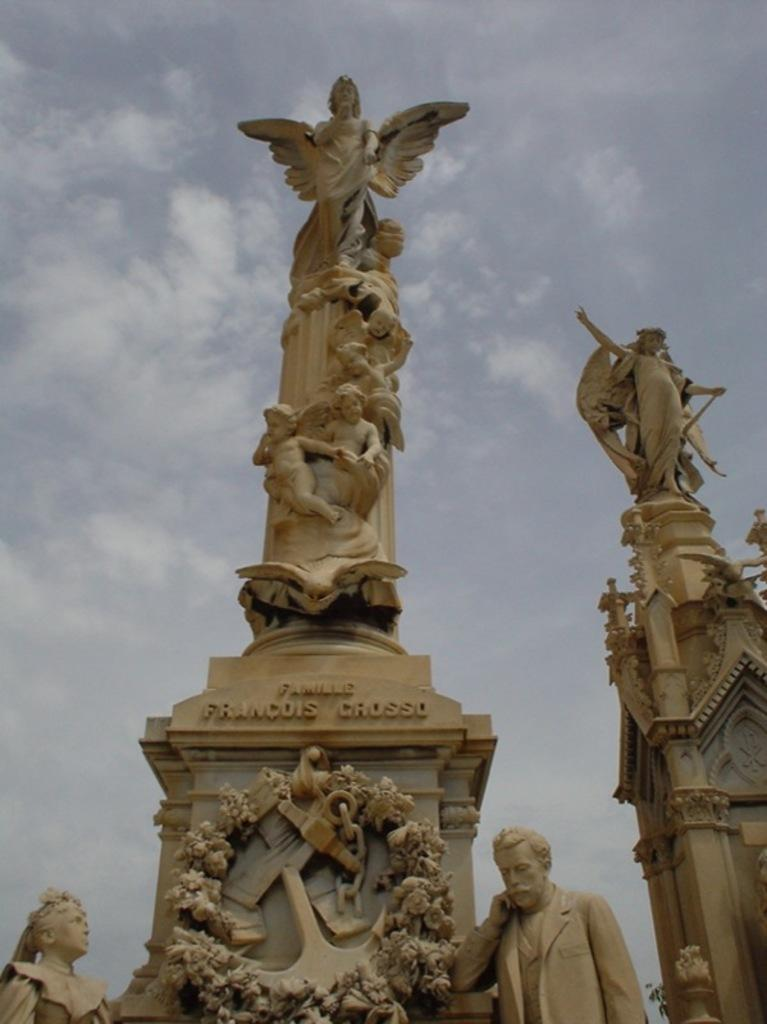What can be seen in the picture? There are statues in the picture. How would you describe the sky in the image? The sky is blue and cloudy. What type of current can be seen flowing near the statues in the image? There is no current visible in the image; it only features statues and a blue, cloudy sky. 